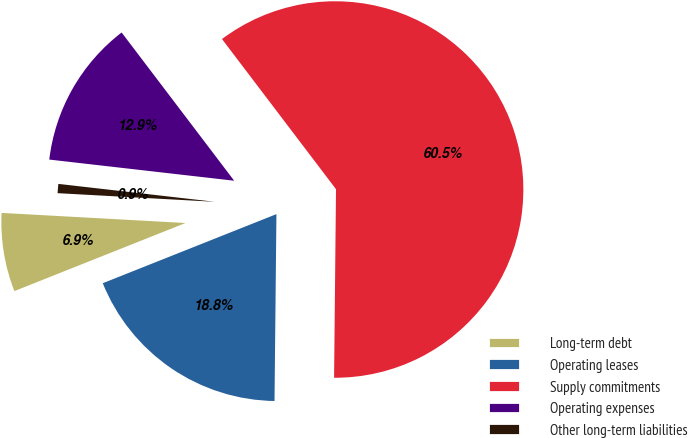Convert chart. <chart><loc_0><loc_0><loc_500><loc_500><pie_chart><fcel>Long-term debt<fcel>Operating leases<fcel>Supply commitments<fcel>Operating expenses<fcel>Other long-term liabilities<nl><fcel>6.9%<fcel>18.81%<fcel>60.5%<fcel>12.85%<fcel>0.94%<nl></chart> 